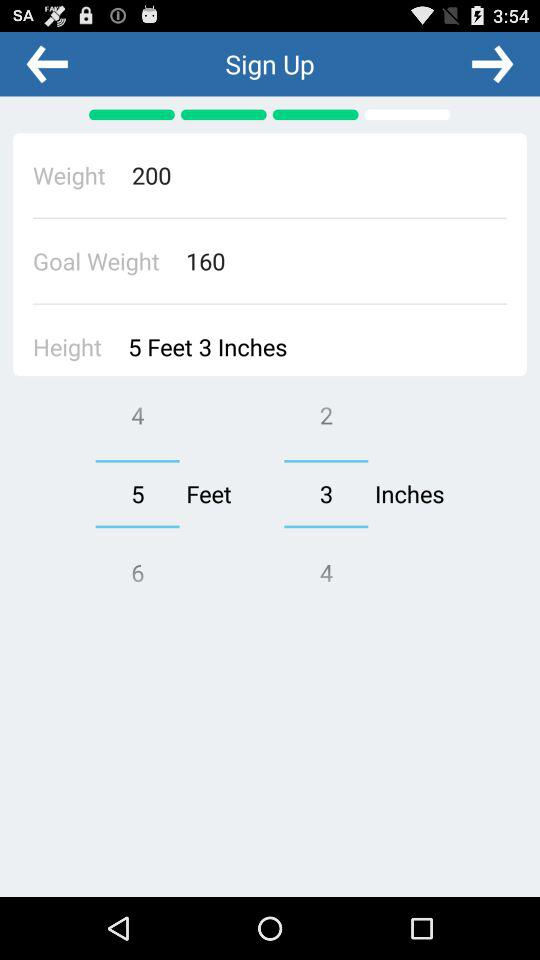What is the goal weight? The goal weight is 160. 